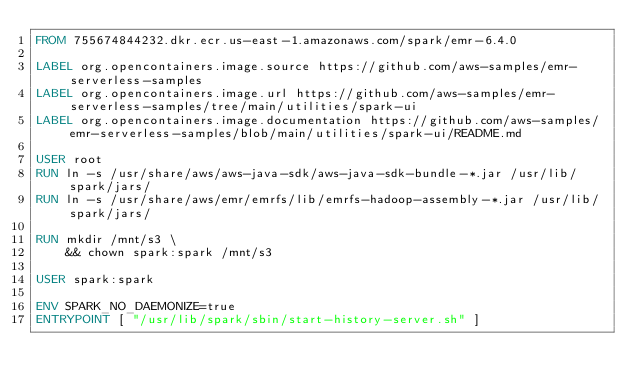<code> <loc_0><loc_0><loc_500><loc_500><_Dockerfile_>FROM 755674844232.dkr.ecr.us-east-1.amazonaws.com/spark/emr-6.4.0

LABEL org.opencontainers.image.source https://github.com/aws-samples/emr-serverless-samples
LABEL org.opencontainers.image.url https://github.com/aws-samples/emr-serverless-samples/tree/main/utilities/spark-ui
LABEL org.opencontainers.image.documentation https://github.com/aws-samples/emr-serverless-samples/blob/main/utilities/spark-ui/README.md

USER root
RUN ln -s /usr/share/aws/aws-java-sdk/aws-java-sdk-bundle-*.jar /usr/lib/spark/jars/
RUN ln -s /usr/share/aws/emr/emrfs/lib/emrfs-hadoop-assembly-*.jar /usr/lib/spark/jars/

RUN mkdir /mnt/s3 \
    && chown spark:spark /mnt/s3

USER spark:spark

ENV SPARK_NO_DAEMONIZE=true
ENTRYPOINT [ "/usr/lib/spark/sbin/start-history-server.sh" ]</code> 